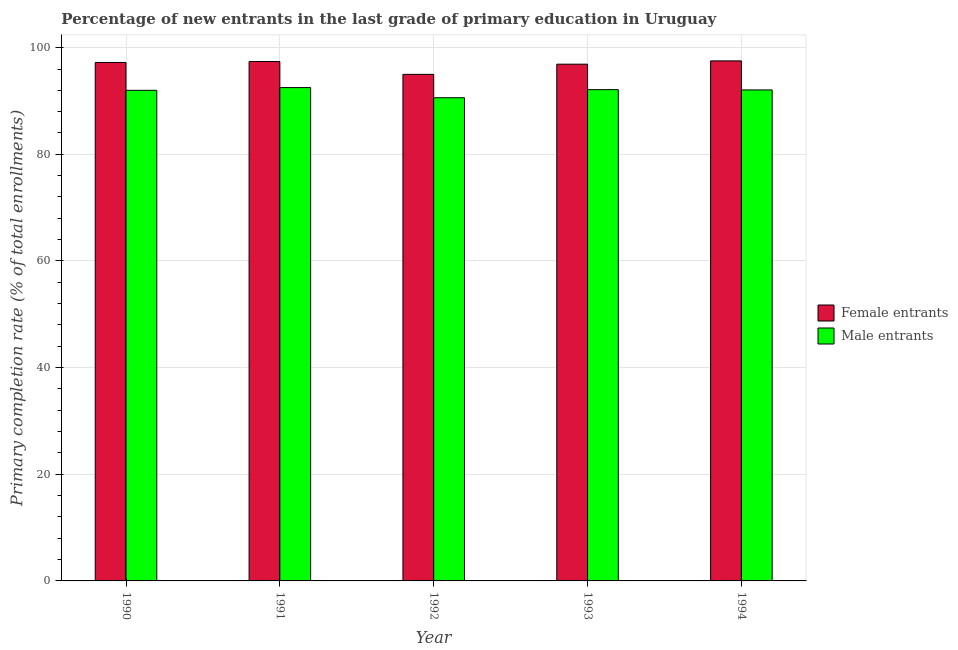How many different coloured bars are there?
Your answer should be compact. 2. How many groups of bars are there?
Your answer should be very brief. 5. How many bars are there on the 2nd tick from the right?
Give a very brief answer. 2. What is the label of the 1st group of bars from the left?
Provide a succinct answer. 1990. In how many cases, is the number of bars for a given year not equal to the number of legend labels?
Give a very brief answer. 0. What is the primary completion rate of female entrants in 1991?
Keep it short and to the point. 97.4. Across all years, what is the maximum primary completion rate of male entrants?
Make the answer very short. 92.52. Across all years, what is the minimum primary completion rate of female entrants?
Give a very brief answer. 95. In which year was the primary completion rate of female entrants maximum?
Offer a very short reply. 1994. In which year was the primary completion rate of male entrants minimum?
Make the answer very short. 1992. What is the total primary completion rate of female entrants in the graph?
Provide a short and direct response. 484.06. What is the difference between the primary completion rate of female entrants in 1992 and that in 1993?
Your response must be concise. -1.91. What is the difference between the primary completion rate of female entrants in 1991 and the primary completion rate of male entrants in 1992?
Your answer should be very brief. 2.41. What is the average primary completion rate of female entrants per year?
Make the answer very short. 96.81. What is the ratio of the primary completion rate of female entrants in 1990 to that in 1994?
Keep it short and to the point. 1. Is the primary completion rate of male entrants in 1990 less than that in 1992?
Your response must be concise. No. What is the difference between the highest and the second highest primary completion rate of male entrants?
Your answer should be very brief. 0.39. What is the difference between the highest and the lowest primary completion rate of male entrants?
Give a very brief answer. 1.91. Is the sum of the primary completion rate of female entrants in 1992 and 1994 greater than the maximum primary completion rate of male entrants across all years?
Offer a terse response. Yes. What does the 1st bar from the left in 1990 represents?
Keep it short and to the point. Female entrants. What does the 2nd bar from the right in 1990 represents?
Make the answer very short. Female entrants. What is the difference between two consecutive major ticks on the Y-axis?
Provide a succinct answer. 20. Are the values on the major ticks of Y-axis written in scientific E-notation?
Your response must be concise. No. Does the graph contain any zero values?
Keep it short and to the point. No. Does the graph contain grids?
Provide a succinct answer. Yes. What is the title of the graph?
Offer a very short reply. Percentage of new entrants in the last grade of primary education in Uruguay. What is the label or title of the X-axis?
Provide a short and direct response. Year. What is the label or title of the Y-axis?
Your response must be concise. Primary completion rate (% of total enrollments). What is the Primary completion rate (% of total enrollments) of Female entrants in 1990?
Provide a succinct answer. 97.23. What is the Primary completion rate (% of total enrollments) of Male entrants in 1990?
Ensure brevity in your answer.  92. What is the Primary completion rate (% of total enrollments) of Female entrants in 1991?
Provide a short and direct response. 97.4. What is the Primary completion rate (% of total enrollments) of Male entrants in 1991?
Offer a very short reply. 92.52. What is the Primary completion rate (% of total enrollments) of Female entrants in 1992?
Give a very brief answer. 95. What is the Primary completion rate (% of total enrollments) of Male entrants in 1992?
Offer a very short reply. 90.61. What is the Primary completion rate (% of total enrollments) of Female entrants in 1993?
Keep it short and to the point. 96.91. What is the Primary completion rate (% of total enrollments) of Male entrants in 1993?
Your answer should be compact. 92.13. What is the Primary completion rate (% of total enrollments) in Female entrants in 1994?
Provide a succinct answer. 97.53. What is the Primary completion rate (% of total enrollments) of Male entrants in 1994?
Give a very brief answer. 92.08. Across all years, what is the maximum Primary completion rate (% of total enrollments) in Female entrants?
Offer a terse response. 97.53. Across all years, what is the maximum Primary completion rate (% of total enrollments) in Male entrants?
Keep it short and to the point. 92.52. Across all years, what is the minimum Primary completion rate (% of total enrollments) in Female entrants?
Your answer should be very brief. 95. Across all years, what is the minimum Primary completion rate (% of total enrollments) of Male entrants?
Provide a succinct answer. 90.61. What is the total Primary completion rate (% of total enrollments) of Female entrants in the graph?
Your response must be concise. 484.06. What is the total Primary completion rate (% of total enrollments) in Male entrants in the graph?
Ensure brevity in your answer.  459.34. What is the difference between the Primary completion rate (% of total enrollments) in Female entrants in 1990 and that in 1991?
Give a very brief answer. -0.17. What is the difference between the Primary completion rate (% of total enrollments) in Male entrants in 1990 and that in 1991?
Offer a terse response. -0.51. What is the difference between the Primary completion rate (% of total enrollments) in Female entrants in 1990 and that in 1992?
Your answer should be very brief. 2.23. What is the difference between the Primary completion rate (% of total enrollments) of Male entrants in 1990 and that in 1992?
Your response must be concise. 1.39. What is the difference between the Primary completion rate (% of total enrollments) of Female entrants in 1990 and that in 1993?
Offer a very short reply. 0.32. What is the difference between the Primary completion rate (% of total enrollments) of Male entrants in 1990 and that in 1993?
Make the answer very short. -0.13. What is the difference between the Primary completion rate (% of total enrollments) of Female entrants in 1990 and that in 1994?
Keep it short and to the point. -0.3. What is the difference between the Primary completion rate (% of total enrollments) of Male entrants in 1990 and that in 1994?
Keep it short and to the point. -0.07. What is the difference between the Primary completion rate (% of total enrollments) in Female entrants in 1991 and that in 1992?
Ensure brevity in your answer.  2.41. What is the difference between the Primary completion rate (% of total enrollments) in Male entrants in 1991 and that in 1992?
Your response must be concise. 1.91. What is the difference between the Primary completion rate (% of total enrollments) in Female entrants in 1991 and that in 1993?
Your response must be concise. 0.5. What is the difference between the Primary completion rate (% of total enrollments) of Male entrants in 1991 and that in 1993?
Offer a terse response. 0.39. What is the difference between the Primary completion rate (% of total enrollments) in Female entrants in 1991 and that in 1994?
Your answer should be compact. -0.12. What is the difference between the Primary completion rate (% of total enrollments) in Male entrants in 1991 and that in 1994?
Provide a short and direct response. 0.44. What is the difference between the Primary completion rate (% of total enrollments) in Female entrants in 1992 and that in 1993?
Your response must be concise. -1.91. What is the difference between the Primary completion rate (% of total enrollments) of Male entrants in 1992 and that in 1993?
Keep it short and to the point. -1.52. What is the difference between the Primary completion rate (% of total enrollments) of Female entrants in 1992 and that in 1994?
Your answer should be very brief. -2.53. What is the difference between the Primary completion rate (% of total enrollments) in Male entrants in 1992 and that in 1994?
Offer a very short reply. -1.46. What is the difference between the Primary completion rate (% of total enrollments) of Female entrants in 1993 and that in 1994?
Provide a succinct answer. -0.62. What is the difference between the Primary completion rate (% of total enrollments) in Male entrants in 1993 and that in 1994?
Offer a very short reply. 0.06. What is the difference between the Primary completion rate (% of total enrollments) in Female entrants in 1990 and the Primary completion rate (% of total enrollments) in Male entrants in 1991?
Your answer should be very brief. 4.71. What is the difference between the Primary completion rate (% of total enrollments) in Female entrants in 1990 and the Primary completion rate (% of total enrollments) in Male entrants in 1992?
Offer a terse response. 6.62. What is the difference between the Primary completion rate (% of total enrollments) of Female entrants in 1990 and the Primary completion rate (% of total enrollments) of Male entrants in 1993?
Make the answer very short. 5.1. What is the difference between the Primary completion rate (% of total enrollments) of Female entrants in 1990 and the Primary completion rate (% of total enrollments) of Male entrants in 1994?
Keep it short and to the point. 5.15. What is the difference between the Primary completion rate (% of total enrollments) of Female entrants in 1991 and the Primary completion rate (% of total enrollments) of Male entrants in 1992?
Offer a terse response. 6.79. What is the difference between the Primary completion rate (% of total enrollments) in Female entrants in 1991 and the Primary completion rate (% of total enrollments) in Male entrants in 1993?
Offer a very short reply. 5.27. What is the difference between the Primary completion rate (% of total enrollments) of Female entrants in 1991 and the Primary completion rate (% of total enrollments) of Male entrants in 1994?
Your response must be concise. 5.33. What is the difference between the Primary completion rate (% of total enrollments) of Female entrants in 1992 and the Primary completion rate (% of total enrollments) of Male entrants in 1993?
Your answer should be very brief. 2.86. What is the difference between the Primary completion rate (% of total enrollments) in Female entrants in 1992 and the Primary completion rate (% of total enrollments) in Male entrants in 1994?
Make the answer very short. 2.92. What is the difference between the Primary completion rate (% of total enrollments) in Female entrants in 1993 and the Primary completion rate (% of total enrollments) in Male entrants in 1994?
Your response must be concise. 4.83. What is the average Primary completion rate (% of total enrollments) in Female entrants per year?
Offer a terse response. 96.81. What is the average Primary completion rate (% of total enrollments) of Male entrants per year?
Your response must be concise. 91.87. In the year 1990, what is the difference between the Primary completion rate (% of total enrollments) in Female entrants and Primary completion rate (% of total enrollments) in Male entrants?
Keep it short and to the point. 5.23. In the year 1991, what is the difference between the Primary completion rate (% of total enrollments) of Female entrants and Primary completion rate (% of total enrollments) of Male entrants?
Offer a terse response. 4.89. In the year 1992, what is the difference between the Primary completion rate (% of total enrollments) in Female entrants and Primary completion rate (% of total enrollments) in Male entrants?
Your response must be concise. 4.38. In the year 1993, what is the difference between the Primary completion rate (% of total enrollments) in Female entrants and Primary completion rate (% of total enrollments) in Male entrants?
Offer a terse response. 4.78. In the year 1994, what is the difference between the Primary completion rate (% of total enrollments) in Female entrants and Primary completion rate (% of total enrollments) in Male entrants?
Make the answer very short. 5.45. What is the ratio of the Primary completion rate (% of total enrollments) in Female entrants in 1990 to that in 1992?
Give a very brief answer. 1.02. What is the ratio of the Primary completion rate (% of total enrollments) of Male entrants in 1990 to that in 1992?
Offer a terse response. 1.02. What is the ratio of the Primary completion rate (% of total enrollments) in Female entrants in 1990 to that in 1993?
Your response must be concise. 1. What is the ratio of the Primary completion rate (% of total enrollments) of Male entrants in 1990 to that in 1993?
Make the answer very short. 1. What is the ratio of the Primary completion rate (% of total enrollments) of Female entrants in 1990 to that in 1994?
Provide a succinct answer. 1. What is the ratio of the Primary completion rate (% of total enrollments) of Female entrants in 1991 to that in 1992?
Offer a terse response. 1.03. What is the ratio of the Primary completion rate (% of total enrollments) in Male entrants in 1991 to that in 1992?
Your response must be concise. 1.02. What is the ratio of the Primary completion rate (% of total enrollments) of Female entrants in 1992 to that in 1993?
Give a very brief answer. 0.98. What is the ratio of the Primary completion rate (% of total enrollments) in Male entrants in 1992 to that in 1993?
Your response must be concise. 0.98. What is the ratio of the Primary completion rate (% of total enrollments) of Female entrants in 1992 to that in 1994?
Your answer should be compact. 0.97. What is the ratio of the Primary completion rate (% of total enrollments) in Male entrants in 1992 to that in 1994?
Ensure brevity in your answer.  0.98. What is the ratio of the Primary completion rate (% of total enrollments) of Female entrants in 1993 to that in 1994?
Keep it short and to the point. 0.99. What is the difference between the highest and the second highest Primary completion rate (% of total enrollments) in Female entrants?
Provide a short and direct response. 0.12. What is the difference between the highest and the second highest Primary completion rate (% of total enrollments) in Male entrants?
Ensure brevity in your answer.  0.39. What is the difference between the highest and the lowest Primary completion rate (% of total enrollments) of Female entrants?
Your response must be concise. 2.53. What is the difference between the highest and the lowest Primary completion rate (% of total enrollments) in Male entrants?
Your answer should be compact. 1.91. 